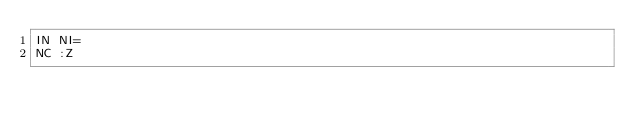<code> <loc_0><loc_0><loc_500><loc_500><_SQL_>IN NI=
NC :Z</code> 